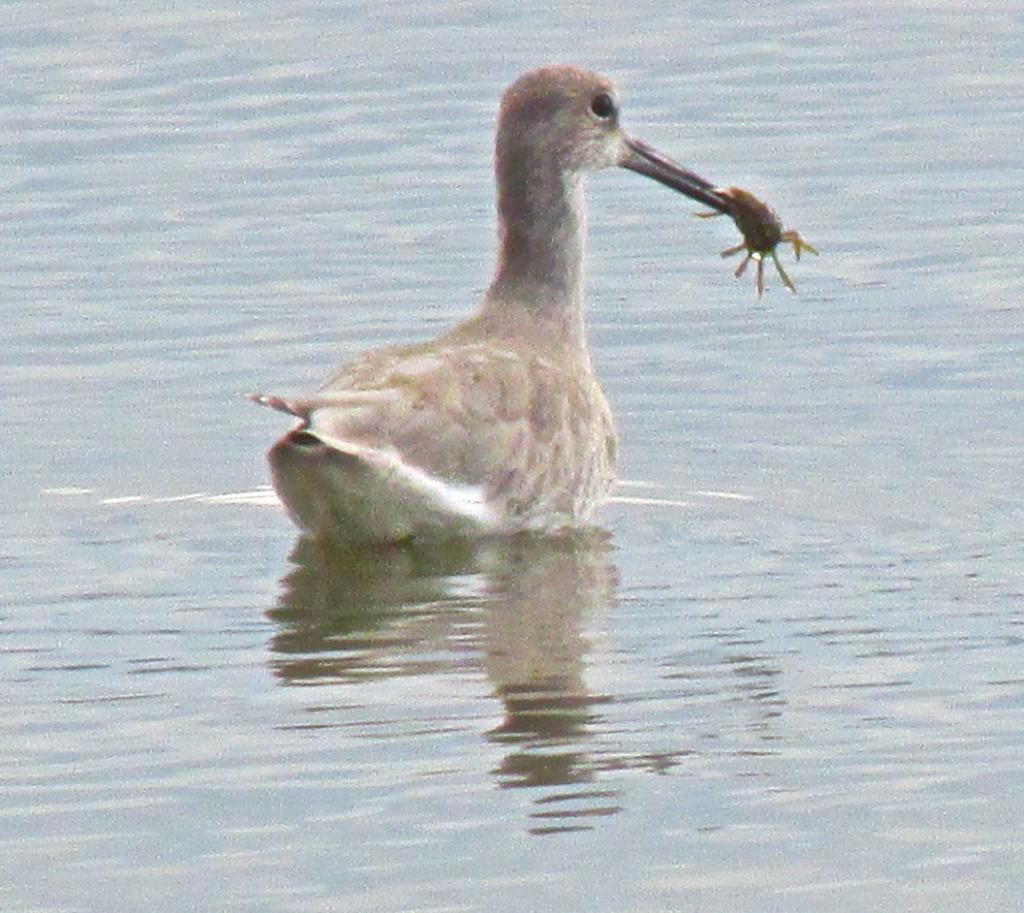What type of animal can be seen in the image? There is a bird in the image. Where is the bird located? The bird is in the water. What is the bird doing in the image? The bird has an insect in its mouth. What type of gun is the bird holding in the image? There is no gun present in the image; the bird has an insect in its mouth. Is the bird performing on a stage in the image? There is no stage present in the image; the bird is in the water. 